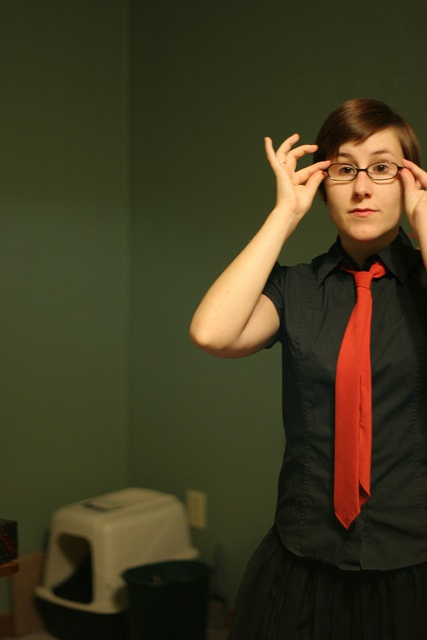Describe the objects in this image and their specific colors. I can see people in black, tan, and brown tones and tie in black, brown, red, and maroon tones in this image. 